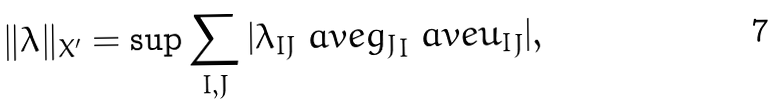<formula> <loc_0><loc_0><loc_500><loc_500>\| \lambda \| _ { X ^ { \prime } } = \sup \sum _ { I , J } | \lambda _ { I J } \ a v e { g _ { J } } _ { I } \ a v e { u _ { I } } _ { J } | ,</formula> 